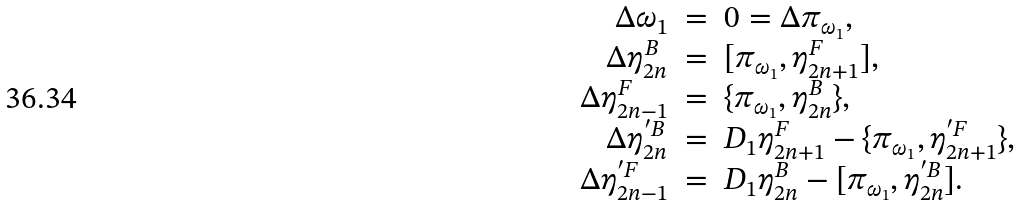<formula> <loc_0><loc_0><loc_500><loc_500>\begin{array} { r c l } \Delta \omega _ { 1 } & = & 0 = \Delta \pi _ { \omega _ { 1 } } , \\ \Delta \eta _ { 2 n } ^ { B } & = & [ \pi _ { \omega _ { 1 } } , \eta _ { 2 n + 1 } ^ { F } ] , \\ \Delta \eta _ { 2 n - 1 } ^ { F } & = & \{ \pi _ { \omega _ { 1 } } , \eta _ { 2 n } ^ { B } \} , \\ \Delta \eta _ { 2 n } ^ { ^ { \prime } B } & = & D _ { 1 } \eta _ { 2 n + 1 } ^ { F } - \{ \pi _ { \omega _ { 1 } } , \eta _ { 2 n + 1 } ^ { ^ { \prime } F } \} , \\ \Delta \eta _ { 2 n - 1 } ^ { ^ { \prime } F } & = & D _ { 1 } \eta _ { 2 n } ^ { B } - [ \pi _ { \omega _ { 1 } } , \eta _ { 2 n } ^ { ^ { \prime } B } ] . \end{array}</formula> 